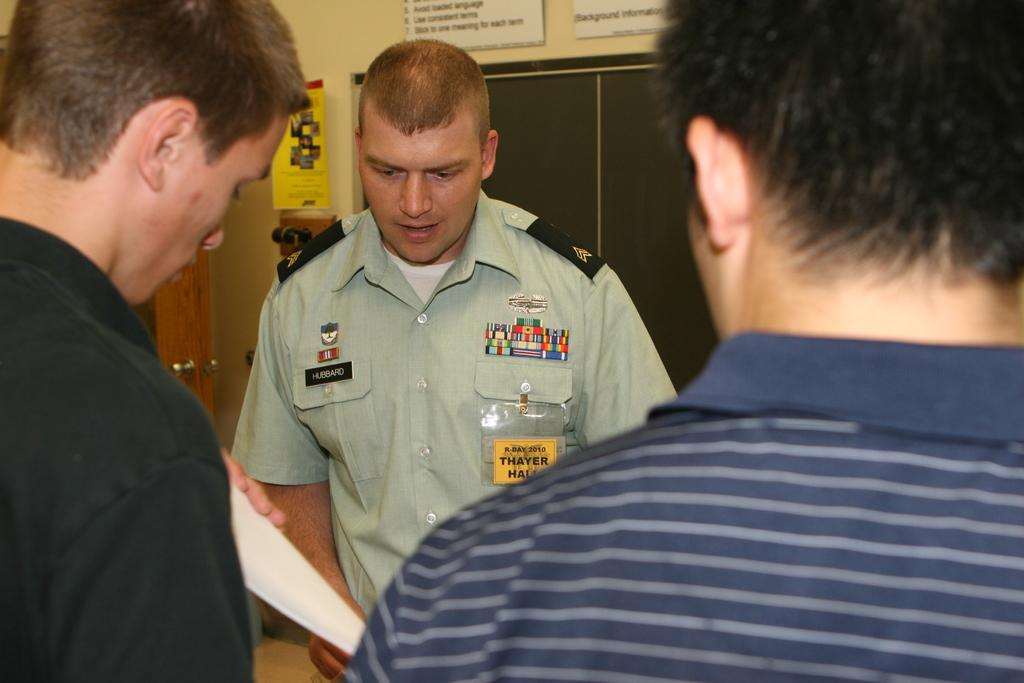<image>
Offer a succinct explanation of the picture presented. A uniformed man named Hubbard is talking to young men and handing thme a form 